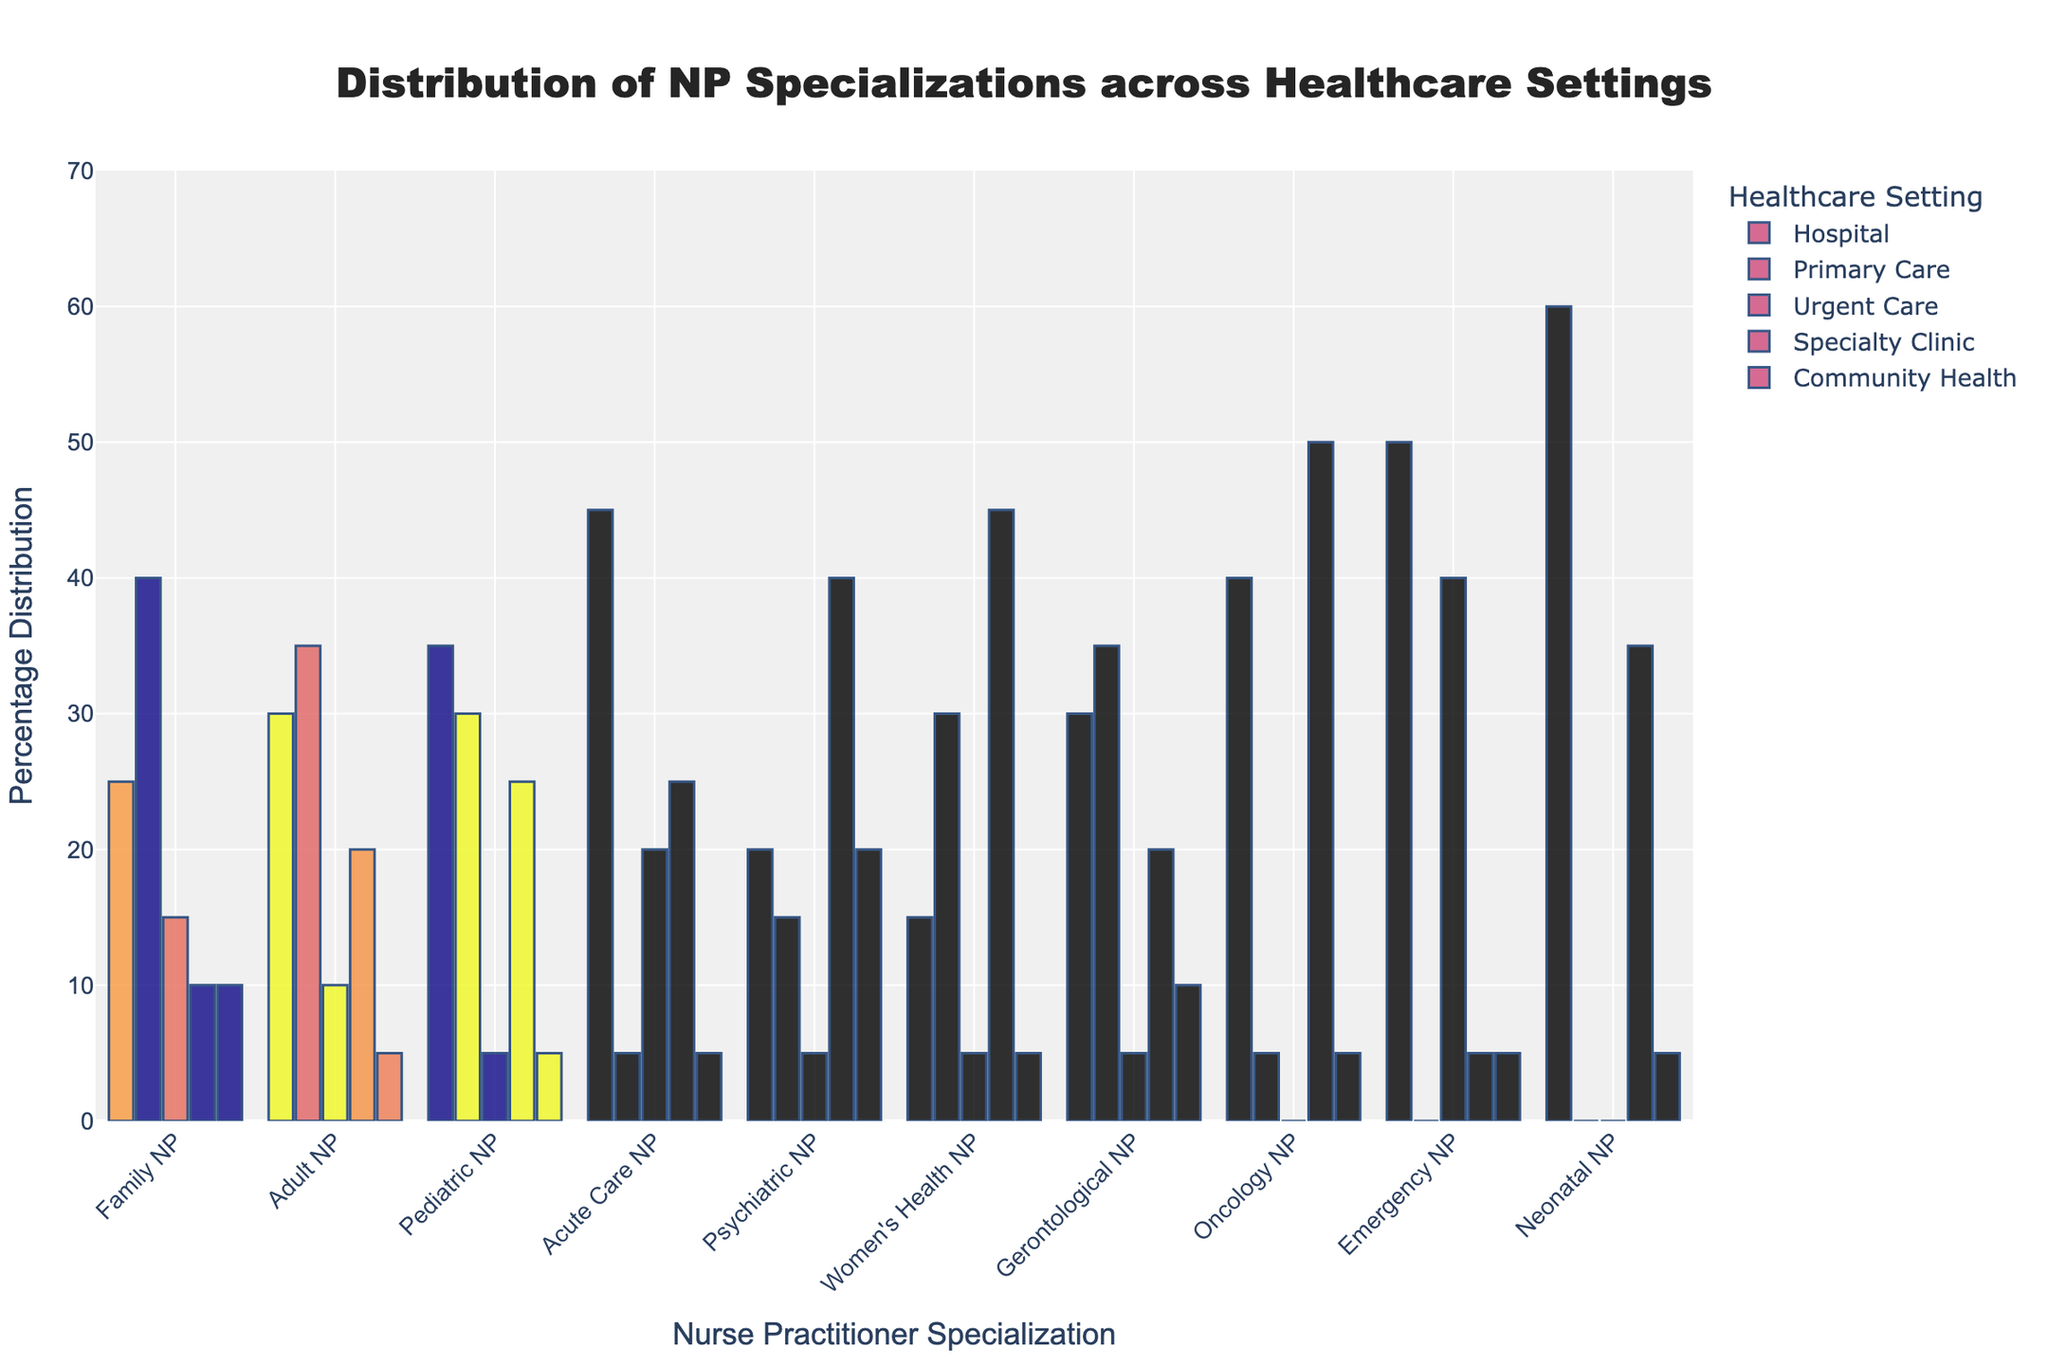Which specialization has the highest percentage in hospital settings? The bar representing the Emergency NP specialization is the tallest in the hospital setting section, indicating the highest percentage.
Answer: Emergency NP Which healthcare setting has the highest distribution of Pediatric NPs? By comparing the bar heights for Pediatric NP across various settings, the Specialty Clinic bar is the highest, indicating the largest percentage.
Answer: Specialty Clinic What is the total distribution percentage of Family NPs across all settings? Adding the values for Family NP across all settings: 25 (Hospital) + 40 (Primary Care) + 15 (Urgent Care) + 10 (Specialty Clinic) + 10 (Community Health) = 100.
Answer: 100 Compare the distribution of Acute Care NPs in Urgent Care and Specialty Clinic settings. The bars representing Acute Care NP in the Urgent Care and Specialty Clinic settings are approximately the same height at 20 and 25, respectively, showing slightly higher distribution in the Specialty Clinic.
Answer: Specialty Clinic is higher Which setting has the least distribution of Gerontological NPs, and what is the percentage? The shortest bar for Gerontological NP appears in the Urgent Care setting at 5.
Answer: Urgent Care, 5 What is the average distribution of Women's Health NPs across all settings? Calculate the average by summing the percentages: 15 (Hospital) + 30 (Primary Care) + 5 (Urgent Care) + 45 (Specialty Clinic) + 5 (Community Health) = 100, then divide by 5 settings.
Answer: 20 Are there any specializations that are not represented in the Urgent Care setting? The Urgent Care percentage bars for Oncology NP and Neonatal NP are at 0, indicating no distribution.
Answer: Oncology NP, Neonatal NP Which specialization has the most balanced distribution across all settings? The bars for Adult NP and Gerontological NP show relatively equal heights across all settings, but Adult NP is distributed more uniformly.
Answer: Adult NP How does the percentage of Psychiatric NPs in Community Health compare to that in Primary Care? The bar for Psychiatric NP in Community Health is taller than in Primary Care, showing a higher distribution in Community Health.
Answer: Community Health is higher 